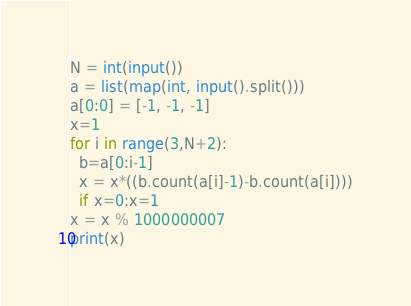Convert code to text. <code><loc_0><loc_0><loc_500><loc_500><_Python_>N = int(input()) 
a = list(map(int, input().split()))
a[0:0] = [-1, -1, -1]
x=1
for i in range(3,N+2):
  b=a[0:i-1]
  x = x*((b.count(a[i]-1)-b.count(a[i])))
  if x=0:x=1
x = x % 1000000007
print(x)</code> 